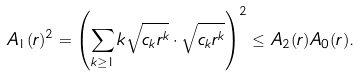<formula> <loc_0><loc_0><loc_500><loc_500>A _ { 1 } ( r ) ^ { 2 } = \left ( \sum _ { k \geq 1 } k \sqrt { c _ { k } r ^ { k } } \cdot \sqrt { c _ { k } r ^ { k } } \right ) ^ { 2 } \leq A _ { 2 } ( r ) A _ { 0 } ( r ) .</formula> 